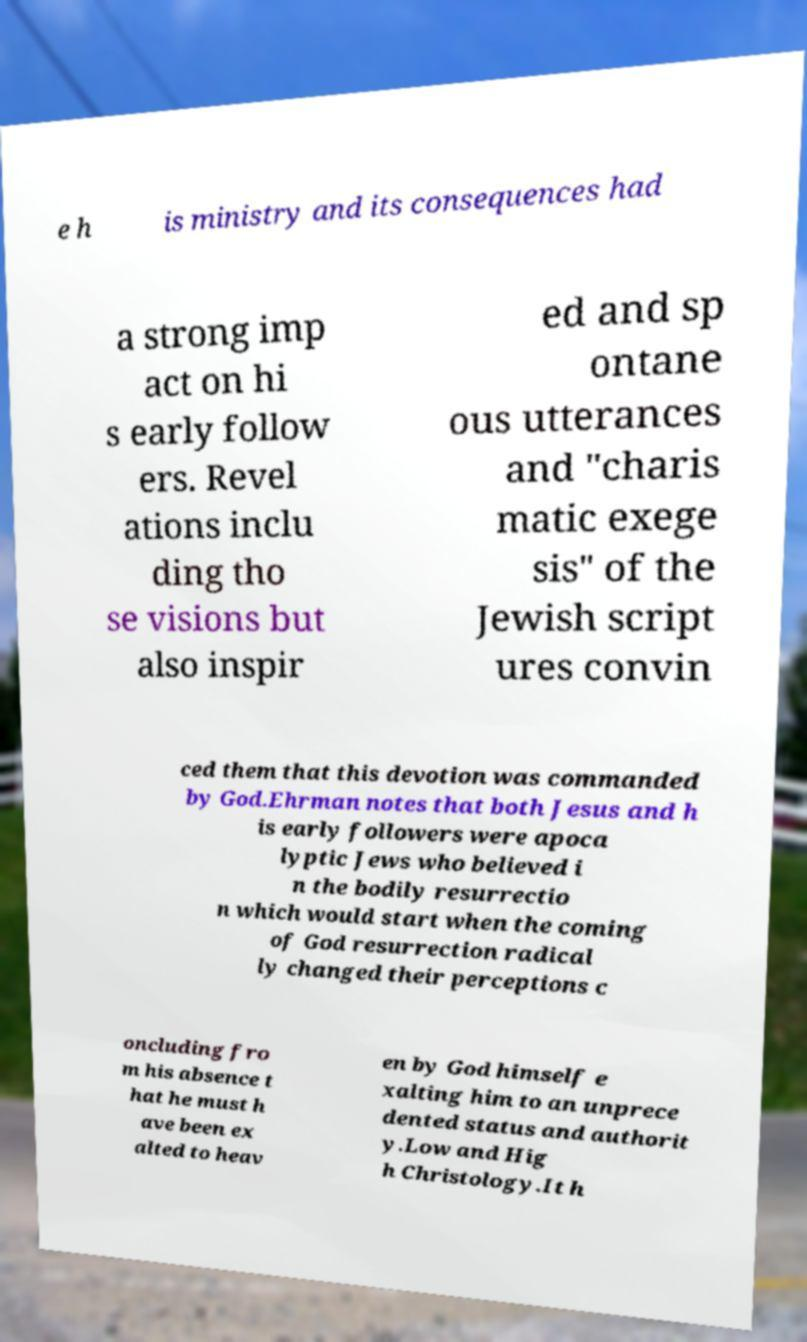Could you extract and type out the text from this image? e h is ministry and its consequences had a strong imp act on hi s early follow ers. Revel ations inclu ding tho se visions but also inspir ed and sp ontane ous utterances and "charis matic exege sis" of the Jewish script ures convin ced them that this devotion was commanded by God.Ehrman notes that both Jesus and h is early followers were apoca lyptic Jews who believed i n the bodily resurrectio n which would start when the coming of God resurrection radical ly changed their perceptions c oncluding fro m his absence t hat he must h ave been ex alted to heav en by God himself e xalting him to an unprece dented status and authorit y.Low and Hig h Christology.It h 